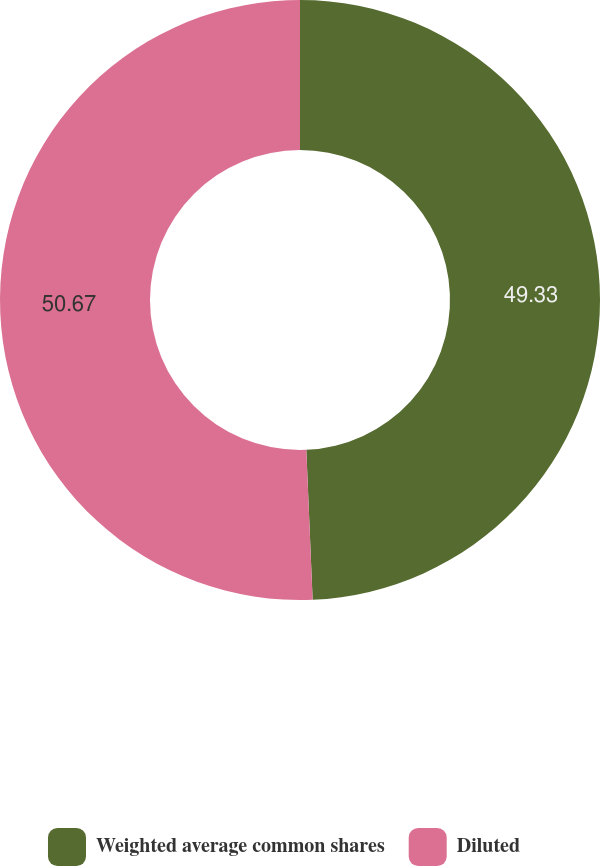Convert chart. <chart><loc_0><loc_0><loc_500><loc_500><pie_chart><fcel>Weighted average common shares<fcel>Diluted<nl><fcel>49.33%<fcel>50.67%<nl></chart> 